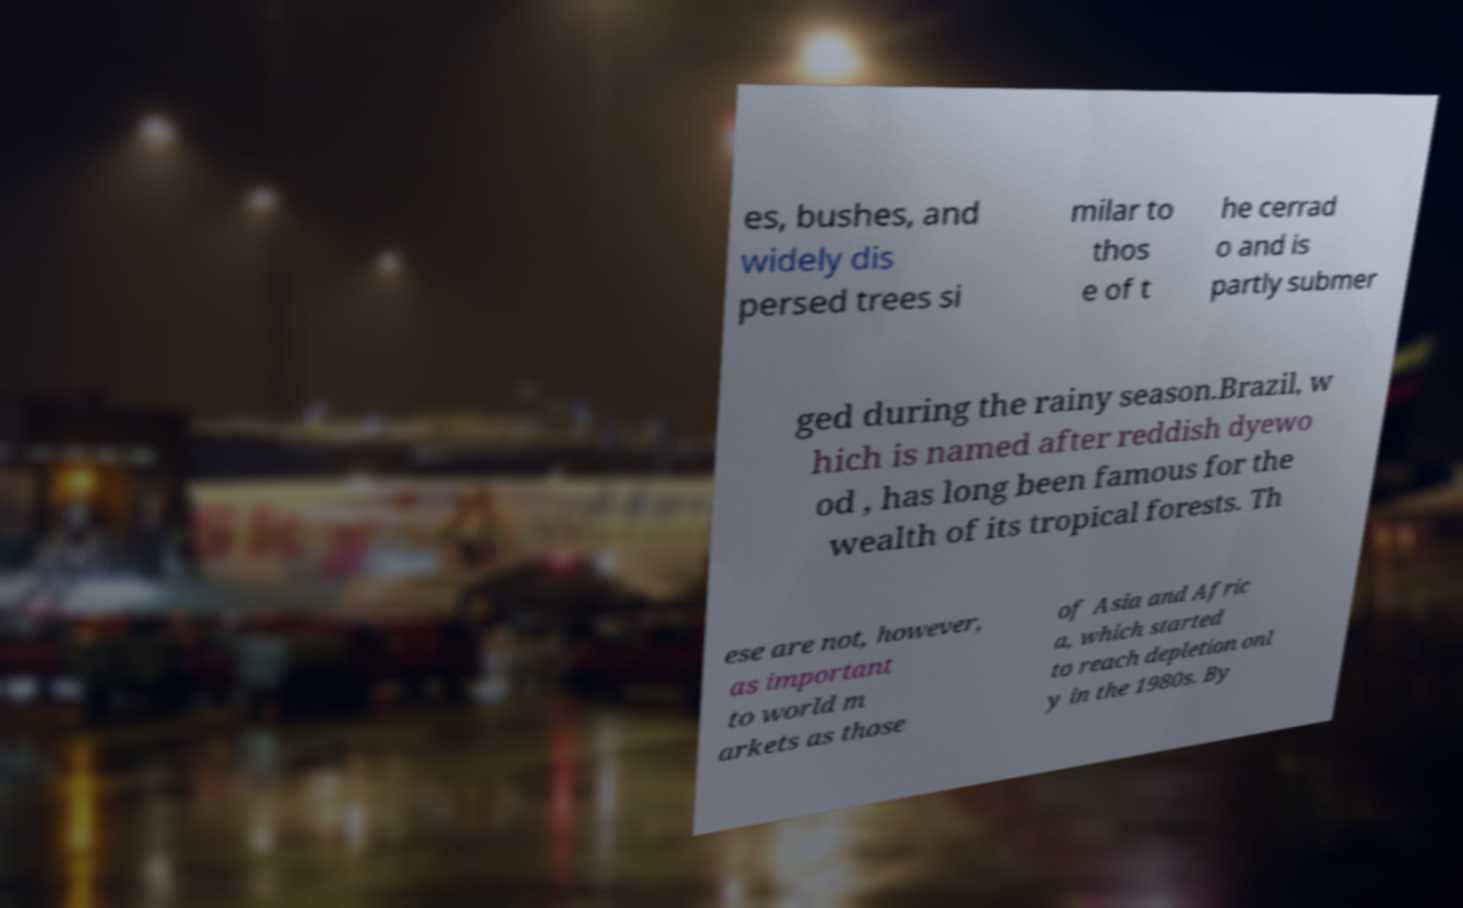For documentation purposes, I need the text within this image transcribed. Could you provide that? es, bushes, and widely dis persed trees si milar to thos e of t he cerrad o and is partly submer ged during the rainy season.Brazil, w hich is named after reddish dyewo od , has long been famous for the wealth of its tropical forests. Th ese are not, however, as important to world m arkets as those of Asia and Afric a, which started to reach depletion onl y in the 1980s. By 